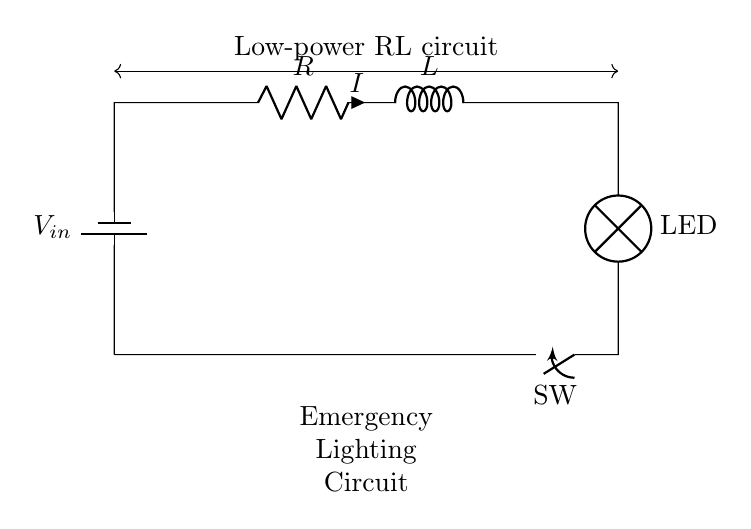what type of circuit is represented here? The circuit is classified as an RL circuit, which consists of a resistor and an inductor in series. The diagram illustrates these components along with a voltage source and a lamp.
Answer: RL circuit how many components are shown in this circuit? By counting the distinct components in the diagram, we find one battery, one resistor, one inductor, one switch, and one lamp. Thus, there are a total of five components.
Answer: five what does the lamp represent in this circuit? The lamp in the circuit symbolizes the load of the circuit which indicates light output when current flows through it. It is connected in series with the resistor and inductor to show how they can power a low-power light.
Answer: LED what is the role of the resistor in this circuit? The resistor limits the current flowing through the circuit, protecting other components from excessive current that could damage them while also allowing some voltage drop for proper operation.
Answer: limit current what happens to the current when the switch is opened? When the switch is opened, it creates an open circuit condition, which interrupts the flow of current. Consequently, no current can pass through any component, including the lamp, causing it to turn off.
Answer: current stops how does inductance affect the circuit's behavior when power is applied? Inductance introduces a time-dependent behavior in the circuit where the current does not instantly reach its maximum value. Instead, it rises gradually due to the inductor's opposition to changes in current, which can help in smoothing out the current flowing to the LED.
Answer: smooth current what is the purpose of including a switch in this circuit? The switch provides a manual means to control the flow of electricity within the circuit, allowing the user to turn the light on or off as needed for convenience and energy conservation.
Answer: control flow 